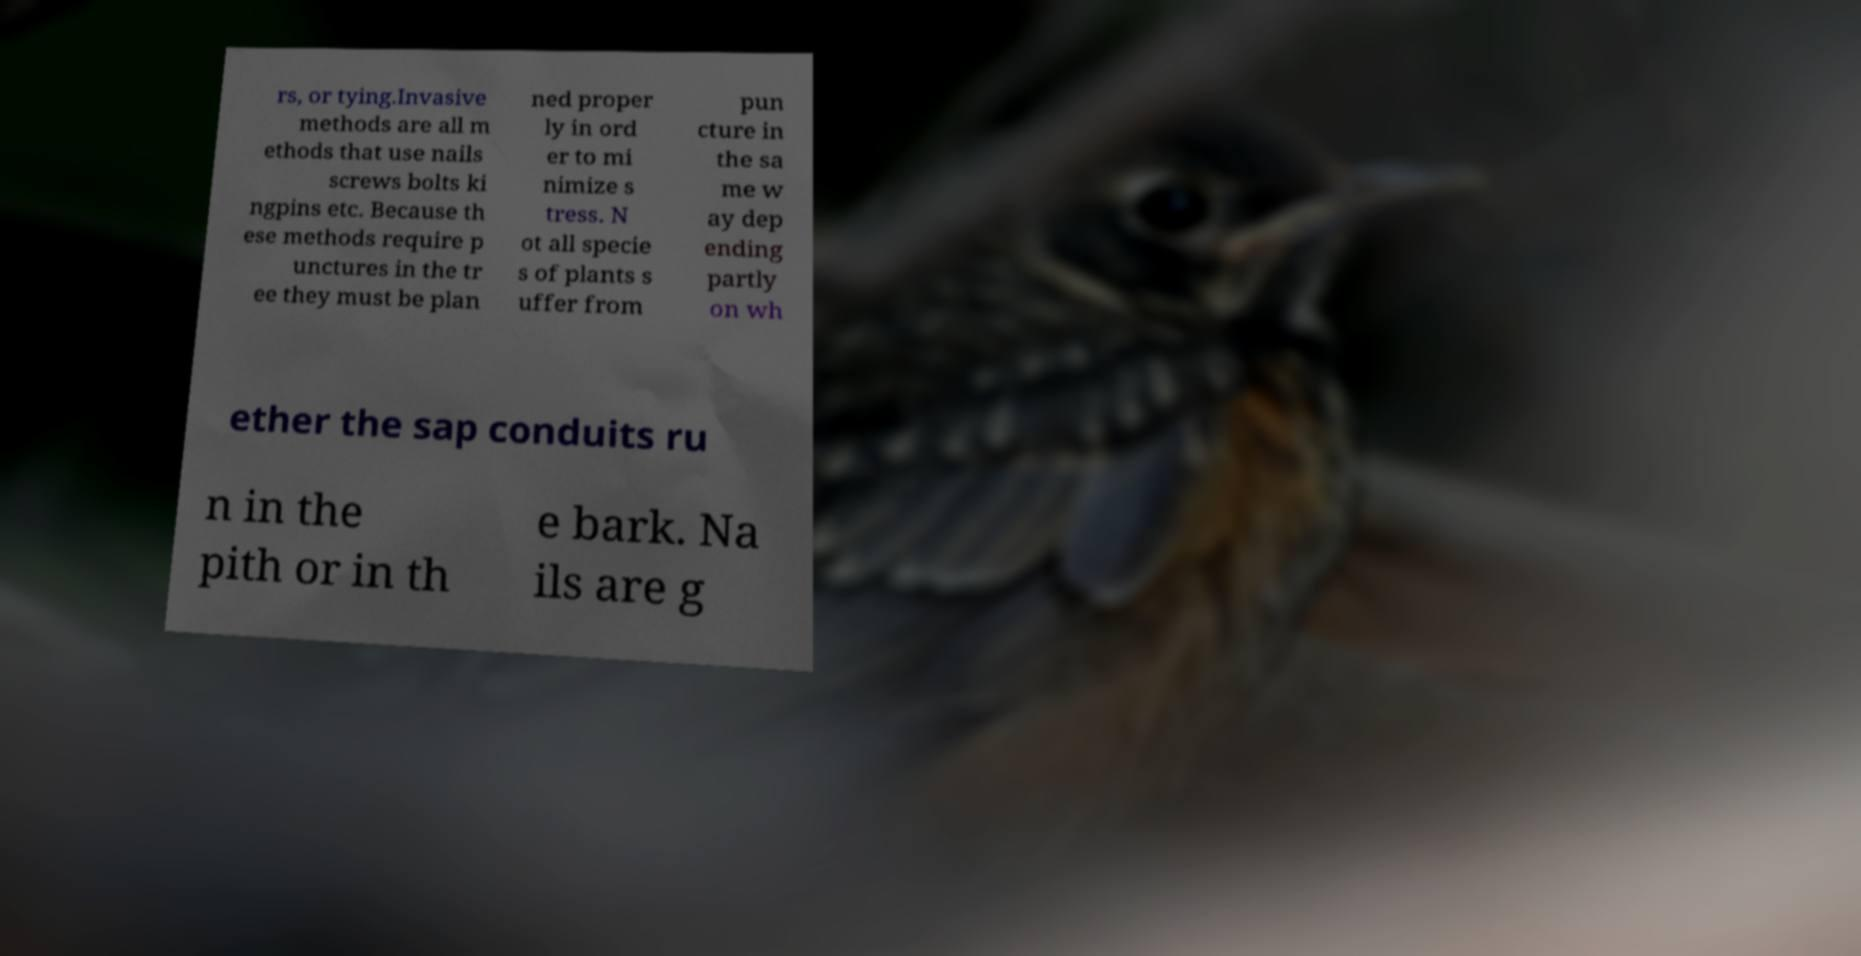Please read and relay the text visible in this image. What does it say? rs, or tying.Invasive methods are all m ethods that use nails screws bolts ki ngpins etc. Because th ese methods require p unctures in the tr ee they must be plan ned proper ly in ord er to mi nimize s tress. N ot all specie s of plants s uffer from pun cture in the sa me w ay dep ending partly on wh ether the sap conduits ru n in the pith or in th e bark. Na ils are g 